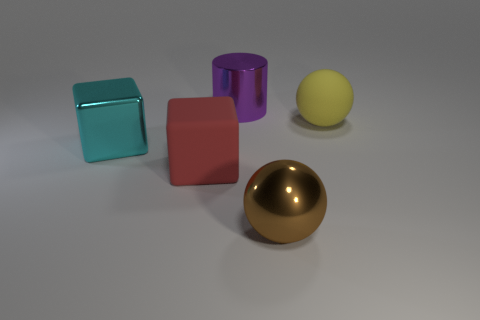Add 5 small green cylinders. How many objects exist? 10 Subtract all balls. How many objects are left? 3 Subtract 1 cyan blocks. How many objects are left? 4 Subtract all big balls. Subtract all big rubber balls. How many objects are left? 2 Add 4 brown shiny balls. How many brown shiny balls are left? 5 Add 3 small cyan rubber balls. How many small cyan rubber balls exist? 3 